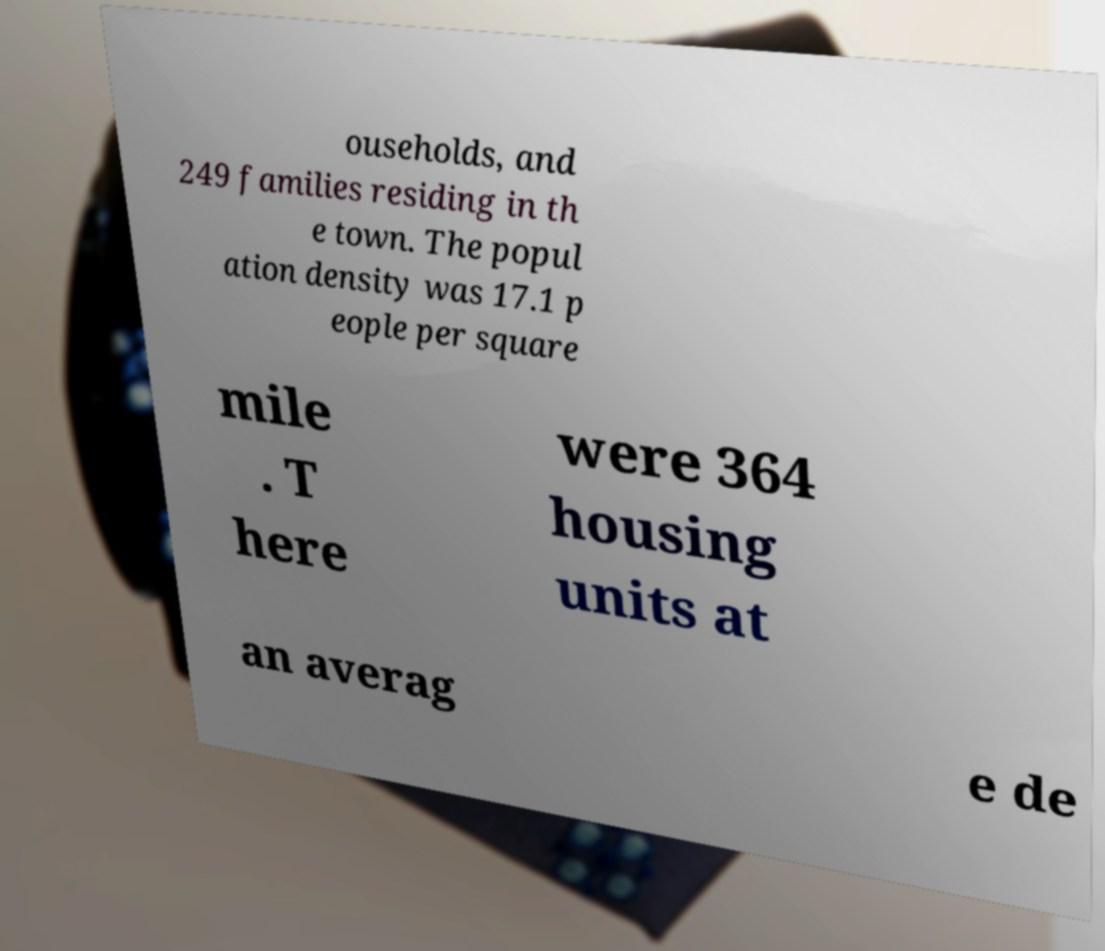Please read and relay the text visible in this image. What does it say? ouseholds, and 249 families residing in th e town. The popul ation density was 17.1 p eople per square mile . T here were 364 housing units at an averag e de 